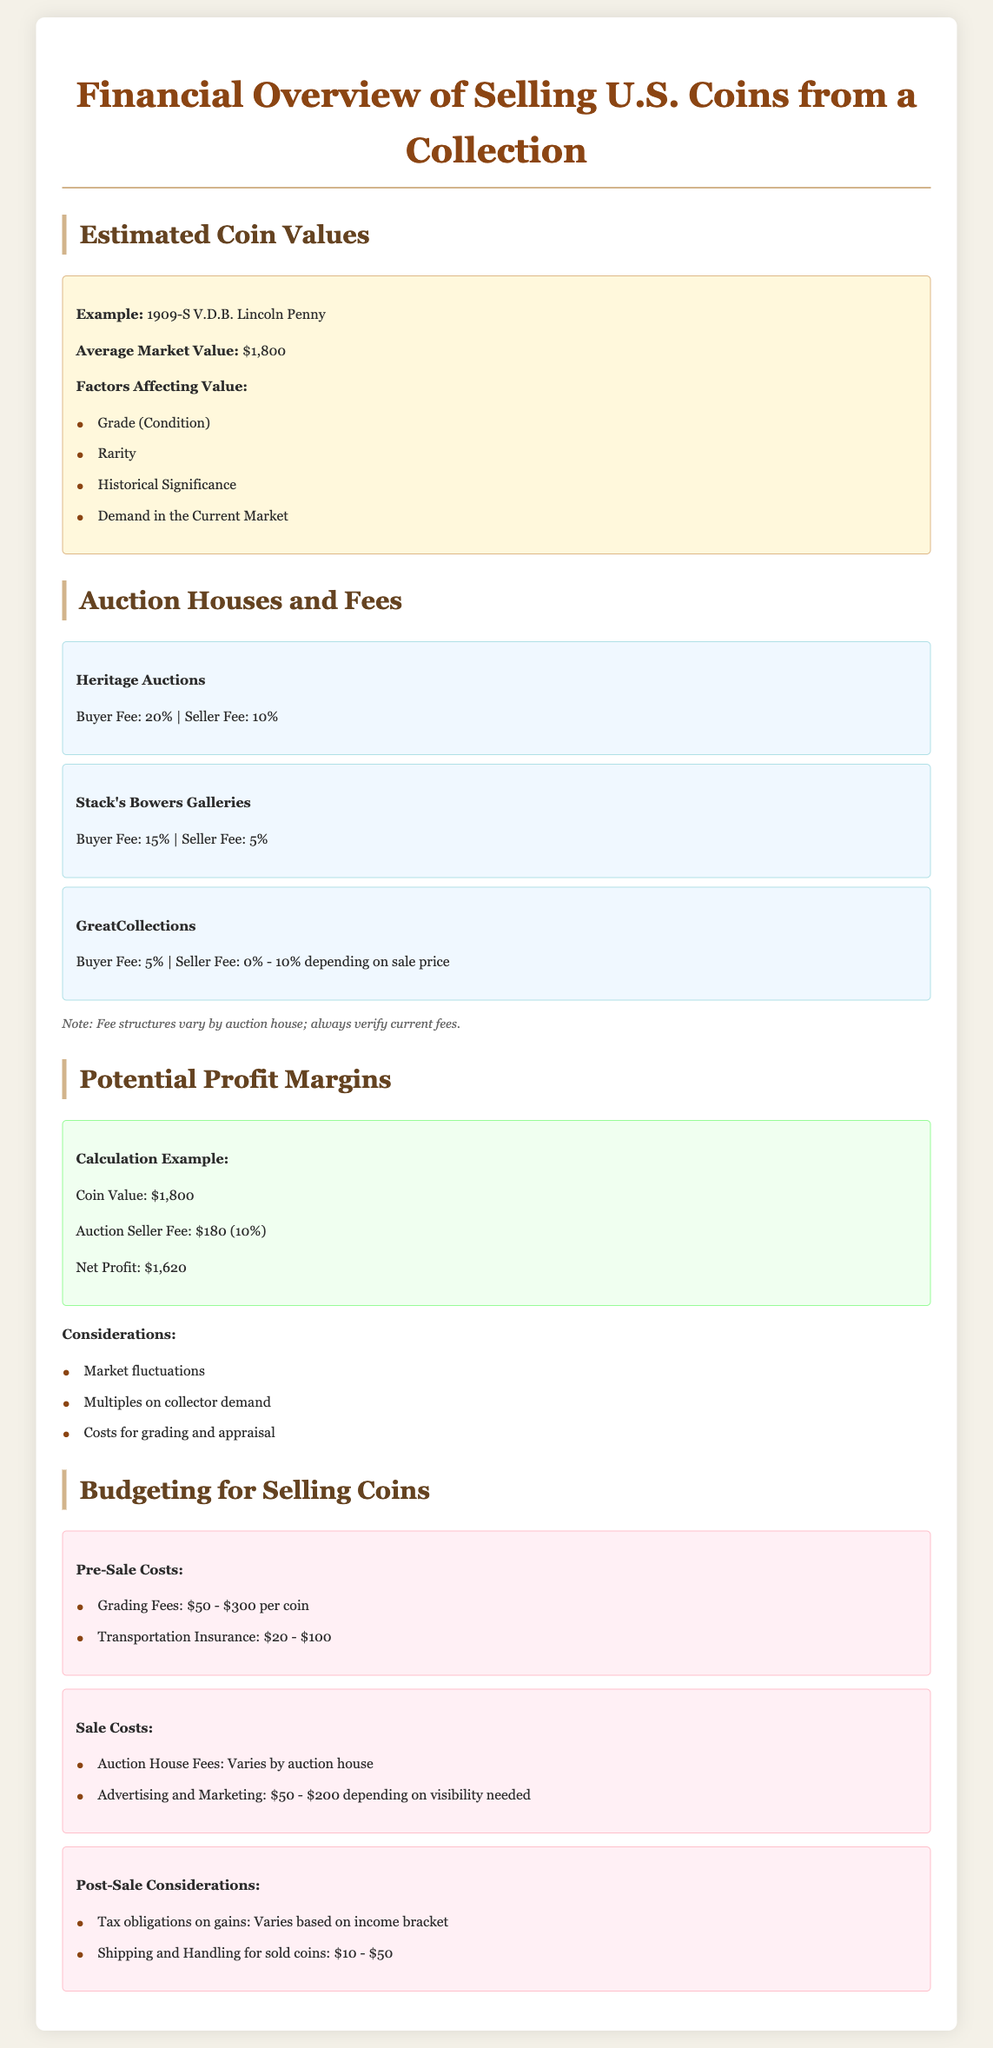What is the average market value of the 1909-S V.D.B. Lincoln Penny? The average market value of the 1909-S V.D.B. Lincoln Penny is stated in the document.
Answer: $1,800 What is the buyer fee percentage from Stack's Bowers Galleries? The buyer fee for Stack's Bowers Galleries is directly mentioned in the auction houses section.
Answer: 15% What is the auction seller fee for Heritage Auctions? The seller fee for Heritage Auctions can be found in the auction houses information provided.
Answer: 10% What are the grading fees range per coin? The pre-sale costs section provides information about the grading fees for coins.
Answer: $50 - $300 What is the potential net profit for a coin valued at $1,800 with a 10% auction seller fee? The net profit calculation example explains how to calculate net profit based on the coin value and seller fee percentage.
Answer: $1,620 What should be considered in post-sale expenses? The post-sale considerations section outlines what should be accounted for after the sale.
Answer: Tax obligations on gains What is the estimated range for transportation insurance? Pre-sale costs section includes estimates for transportation insurance.
Answer: $20 - $100 What is the advertising and marketing cost range mentioned? The document specifies costs associated with advertising and marketing under sale costs.
Answer: $50 - $200 What factors affect the value of a coin? The factors that contribute to a coin's value are listed in the coin example section.
Answer: Grade, Rarity, Historical Significance, Demand 